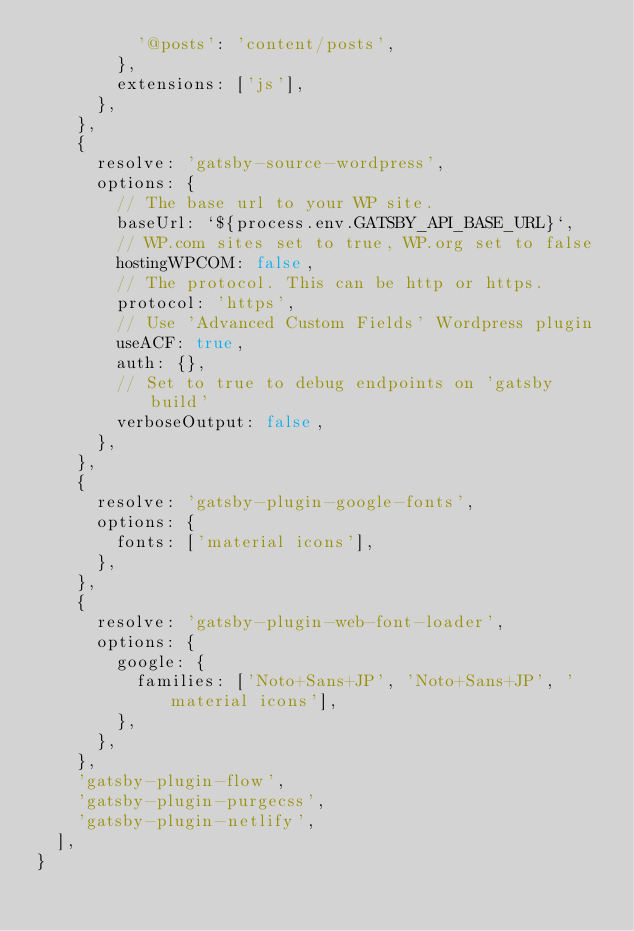<code> <loc_0><loc_0><loc_500><loc_500><_JavaScript_>          '@posts': 'content/posts',
        },
        extensions: ['js'],
      },
    },
    {
      resolve: 'gatsby-source-wordpress',
      options: {
        // The base url to your WP site.
        baseUrl: `${process.env.GATSBY_API_BASE_URL}`,
        // WP.com sites set to true, WP.org set to false
        hostingWPCOM: false,
        // The protocol. This can be http or https.
        protocol: 'https',
        // Use 'Advanced Custom Fields' Wordpress plugin
        useACF: true,
        auth: {},
        // Set to true to debug endpoints on 'gatsby build'
        verboseOutput: false,
      },
    },
    {
      resolve: 'gatsby-plugin-google-fonts',
      options: {
        fonts: ['material icons'],
      },
    },
    {
      resolve: 'gatsby-plugin-web-font-loader',
      options: {
        google: {
          families: ['Noto+Sans+JP', 'Noto+Sans+JP', 'material icons'],
        },
      },
    },
    'gatsby-plugin-flow',
    'gatsby-plugin-purgecss',
    'gatsby-plugin-netlify',
  ],
}
</code> 